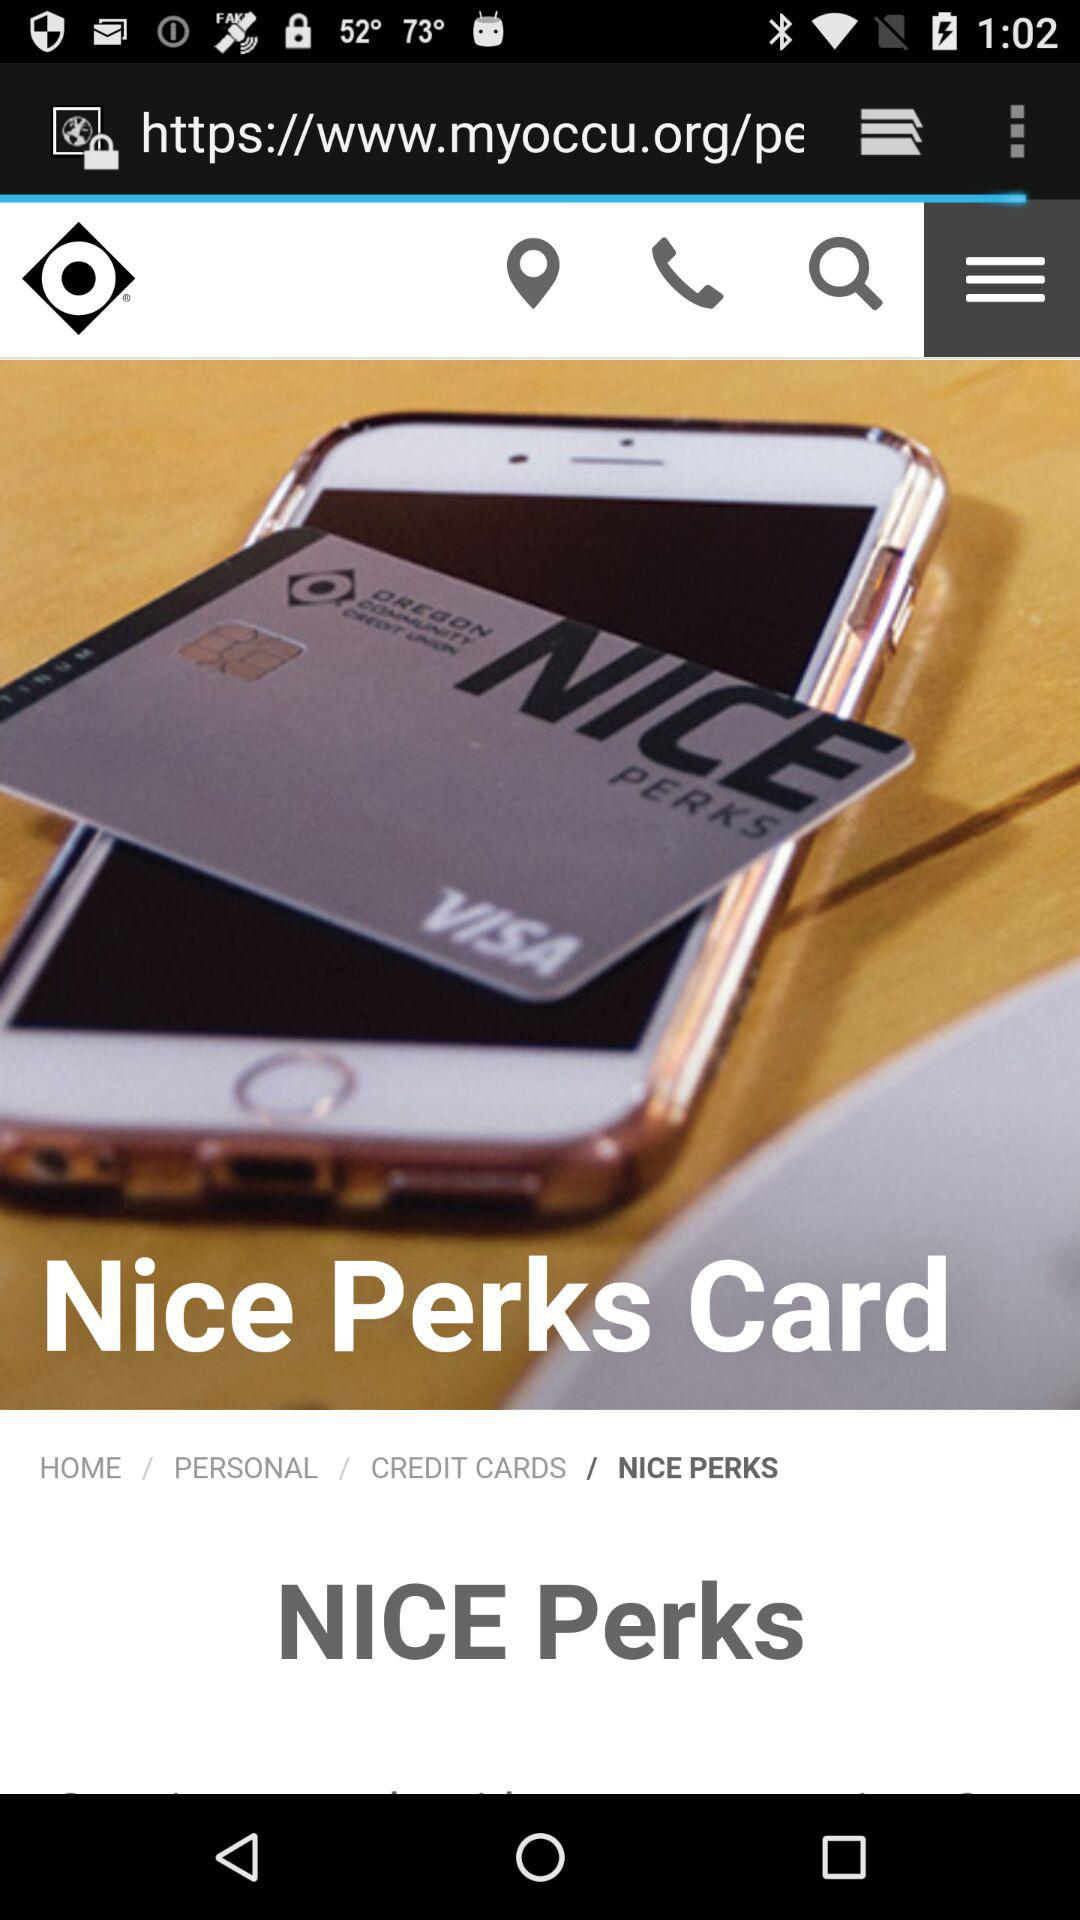What is the card name? The card name is Nice Perks. 